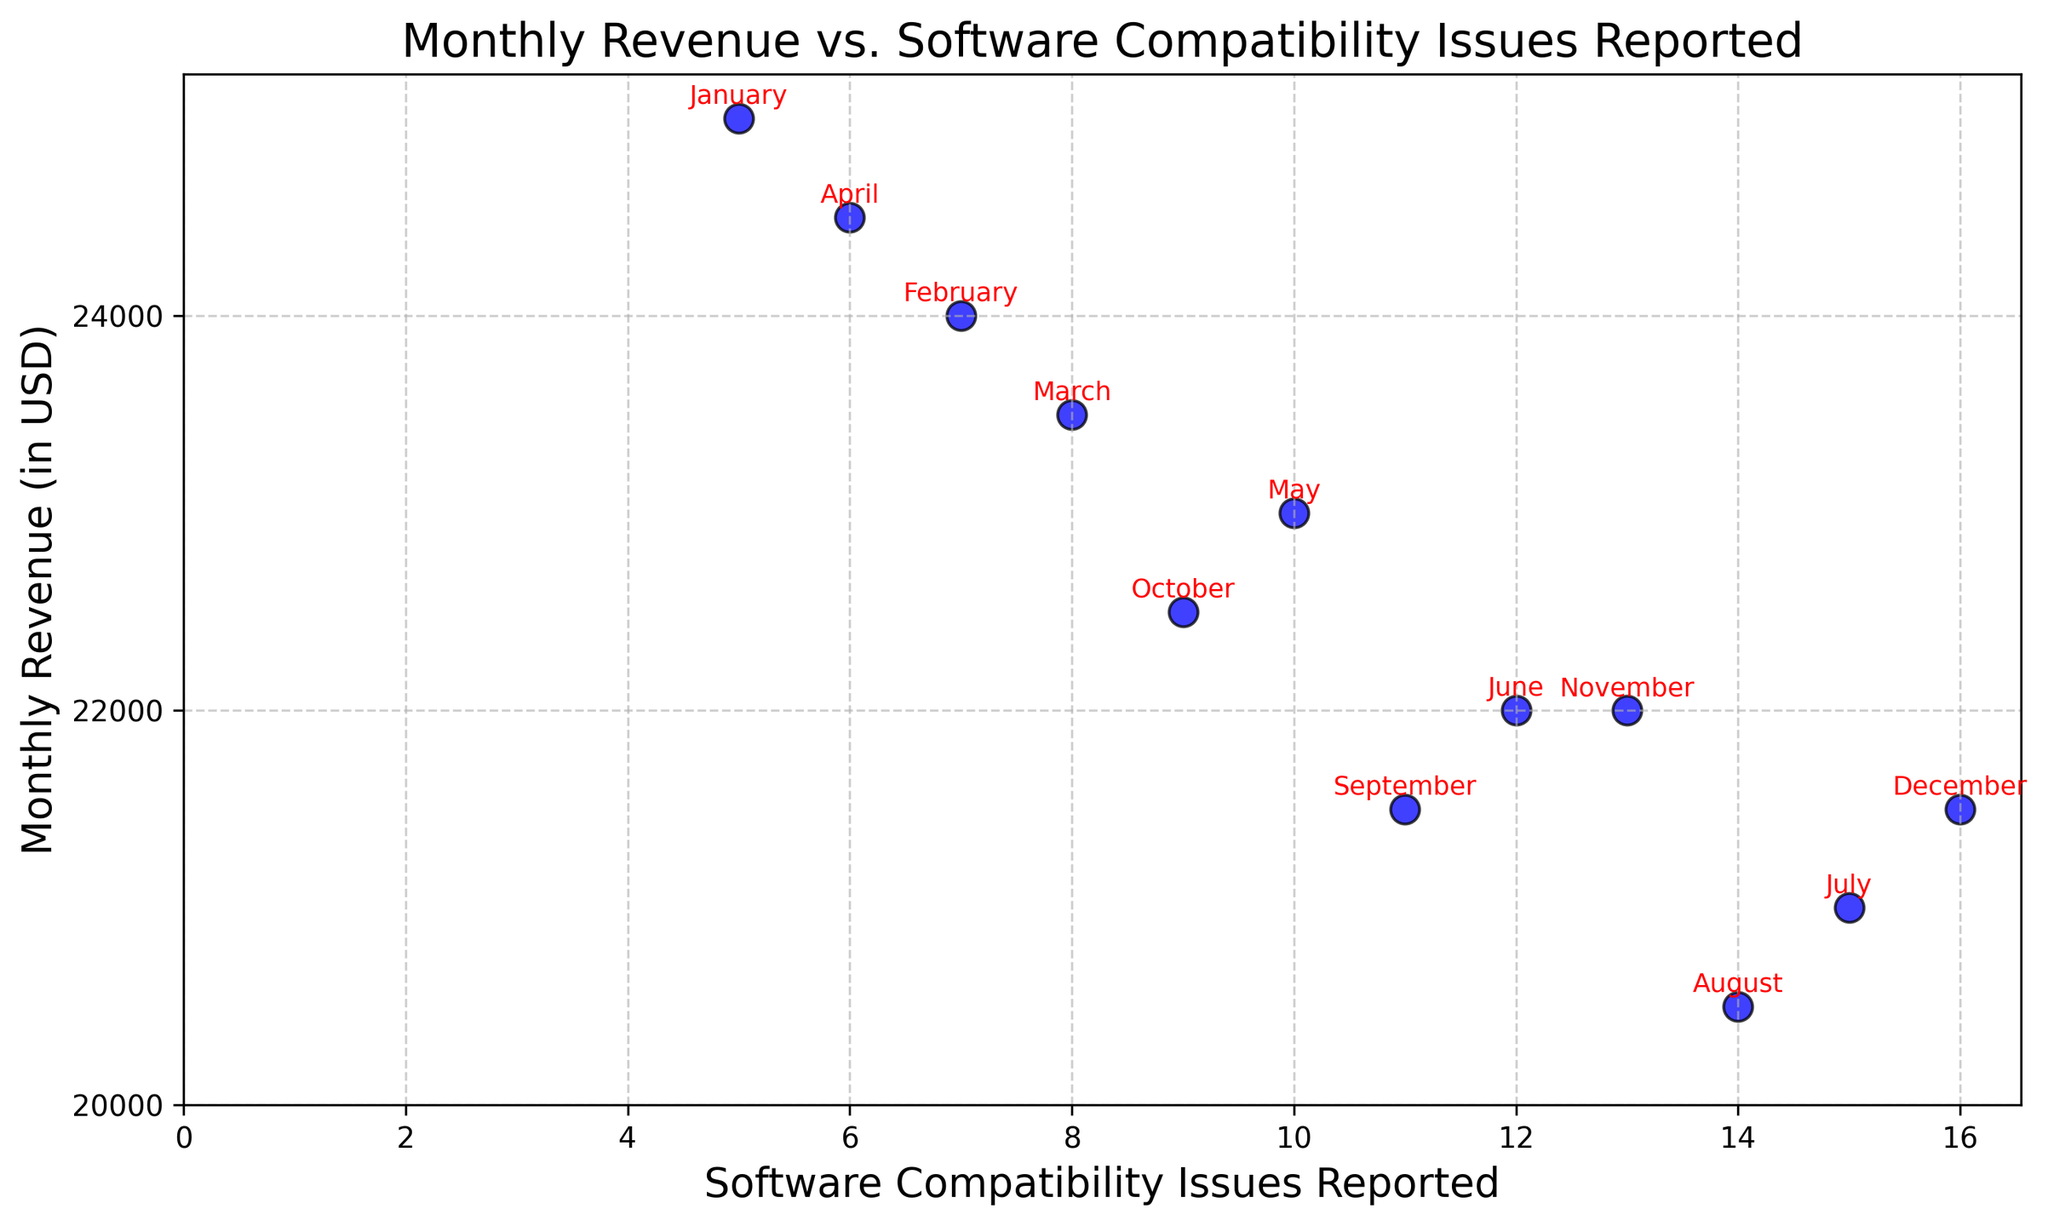What's the month with the highest number of software compatibility issues reported? Look at the scatter plot and identify the point at the furthest right, which represents the highest number of issues reported. From the annotation, this point corresponds to December.
Answer: December Which month has the lowest monthly revenue? Identify the lowest point on the y-axis, which represents monthly revenue. The annotation shows that this is August.
Answer: August Is there a general trend in monthly revenue as the number of software compatibility issues reported increases? Observing the scatter plot, you can see that as the number of software compatibility issues reported increases, the monthly revenue generally decreases.
Answer: Monthly revenue decreases What's the average monthly revenue for months with more than 10 software compatibility issues reported? Identify the months with more than 10 issues: May, June, July, August, September, November, December. Calculate the average revenue for these months: (23000 + 22000 + 21000 + 20500 + 21500 + 22000 + 21500)/7 = 21642.86.
Answer: 21642.86 Between April and May, which month had more software compatibility issues reported, and what was the difference in their monthly revenues? From the scatter plot, April had 6 issues and May had 10 issues. April's revenue was $24500 and May's was $23000. The difference in their revenue is $24500 - $23000 = $1500.
Answer: May, $1500 How many months had a monthly revenue below $22000? Count the number of points below the $22000 line on the y-axis. The points corresponding to June, July, August, November, and December are below $22000.
Answer: 5 What's the median number of software compatibility issues reported across all months? List the number of issues reported (5, 7, 8, 6, 10, 12, 15, 14, 11, 9, 13, 16) and find the middle value(s). The median is the average of the 6th and 7th values: (10 + 11)/2 = 10.5.
Answer: 10.5 Which month had the highest revenue, and how many software compatibility issues were reported that month? Find the highest point on the y-axis, which represents monthly revenue. January had the highest revenue of $25000 and reported 5 issues.
Answer: January, 5 Comparing March and October, which month had more software compatibility issues reported, and what were their respective revenues? From the scatter plot, March had 8 issues and October had 9 issues. March's revenue was $23500, and October's was $22500.
Answer: October, March: $23500, October: $22500 